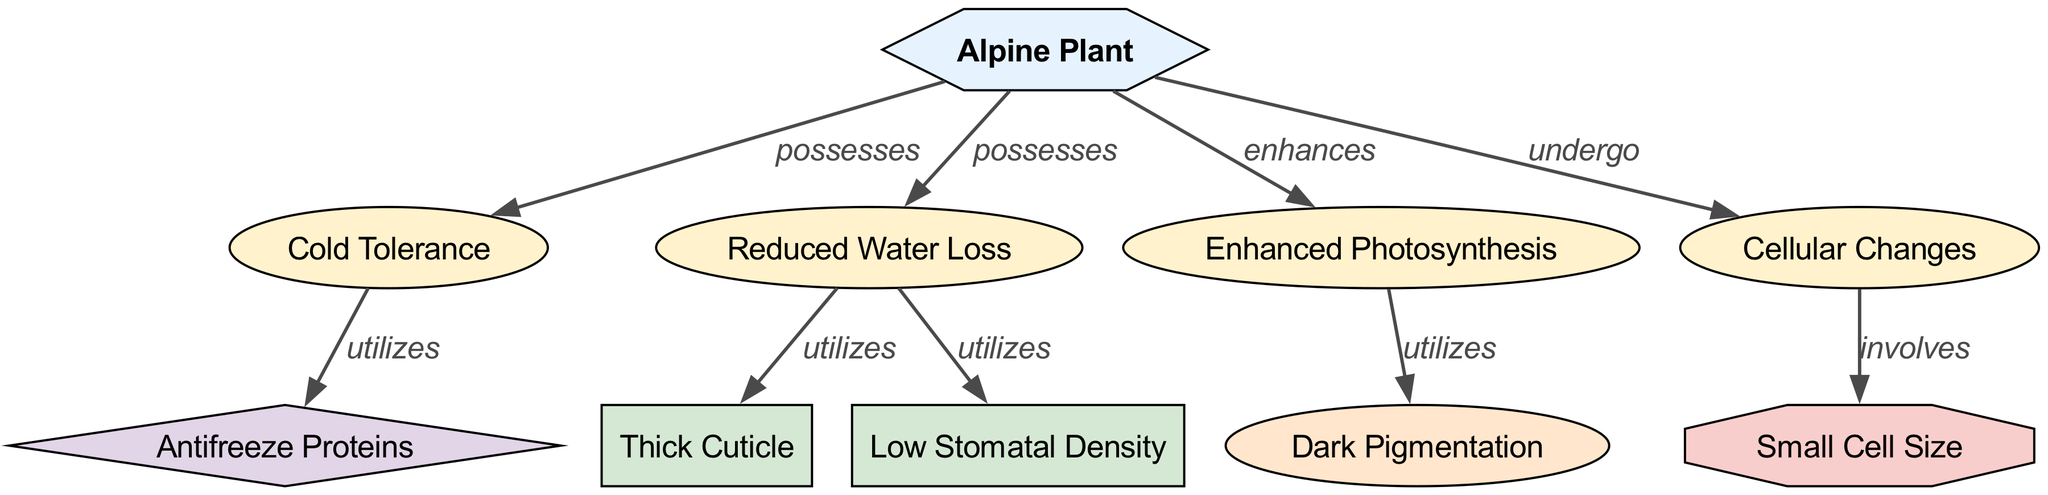What is the main entity depicted in the diagram? The diagram centers around Alpine Plants, which are specifically adapted to survive and thrive at high altitudes. The label for the main entity node emphasizes its role as the focal point of adaptations showcased in the diagram.
Answer: Alpine Plant How many attributes are present in the diagram? By reviewing the nodes categorized as attributes, we find a total of four specific attributes associated with Alpine Plants, namely Cold Tolerance, Reduced Water Loss, Enhanced Photosynthesis, and Cellular Changes.
Answer: 4 Which biochemical adaptation is utilized for cold tolerance? The diagram depicts that cold tolerance in Alpine Plants utilizes Antifreeze Proteins, which are specifically mentioned as the mechanism to prevent ice crystal formation in plant cells, thus helping in cold environments.
Answer: Antifreeze Proteins What structural adaptation reduces water loss? According to the diagram, the Thick Cuticle is a structural adaptation that minimizes water loss in Alpine Plants. This is a specific feature noted under the Reduced Water Loss attribute.
Answer: Thick Cuticle Which physiological adaptation absorbs more light? The diagram illustrates that Dark Pigmentation serves as a physiological adaptation that allows Alpine Plants to absorb more light, which is crucial for surviving in lower light conditions at high altitudes.
Answer: Dark Pigmentation How does the cellular change involve small cell size? The diagram indicates that the cellular changes undergone by Alpine Plants involve Small Cell Size, which is associated with increasing heat retention necessary for survival in cold climates. This relationship can be traced from Cellular Changes to Small Cell Size.
Answer: Small Cell Size What is the relationship between Reduced Water Loss and Low Stomatal Density? The diagram demonstrates that Reduced Water Loss utilizes Low Stomatal Density as a way to minimize transpiration. This connection signifies how the structural adaptation works in concert with other features to enhance the plant's adaptability in alpine environments.
Answer: utilizes How many edges connect the attributes to the alpine plant? Upon examining the edges that connect attributes to the Alpine Plant node, there are a total of four edges signifying these connections, highlighting the various adaptations that Alpine Plants possess.
Answer: 4 Which adaptation enhances photosynthesis? The diagram specifies that Enhanced Photosynthesis is achieved through the utilization of Dark Pigmentation, which allows Alpine Plants to maximize light absorption despite lower light availability at high altitudes.
Answer: Dark Pigmentation 